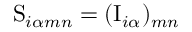<formula> <loc_0><loc_0><loc_500><loc_500>S _ { i \alpha m n } = ( I _ { i \alpha } ) _ { m n }</formula> 